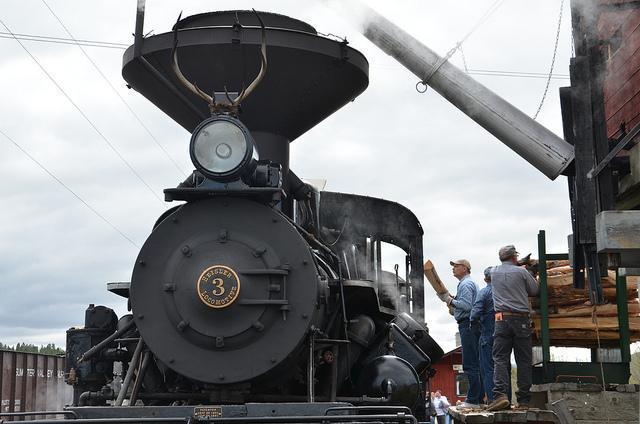How many people are in the photo?
Give a very brief answer. 2. 